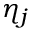Convert formula to latex. <formula><loc_0><loc_0><loc_500><loc_500>\eta _ { j }</formula> 